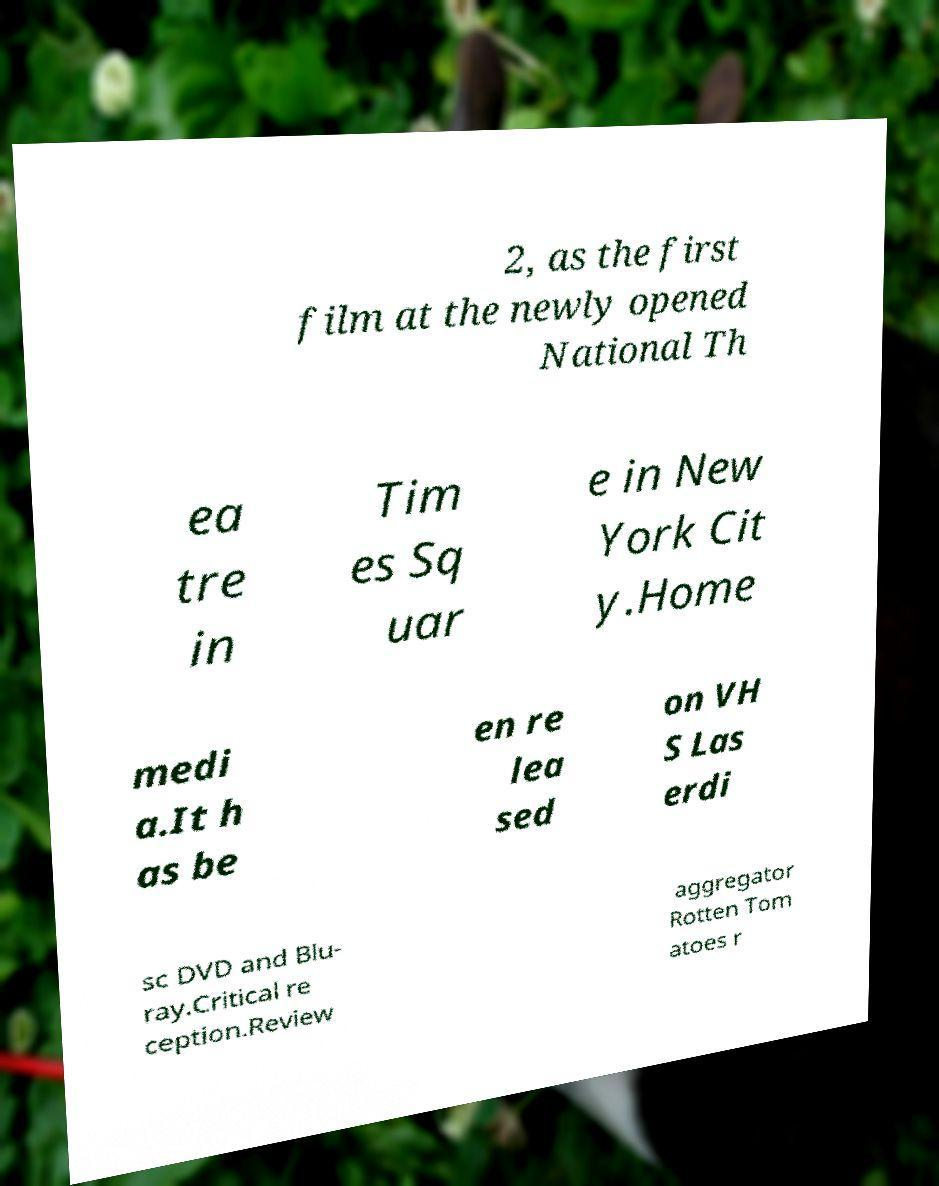Can you accurately transcribe the text from the provided image for me? 2, as the first film at the newly opened National Th ea tre in Tim es Sq uar e in New York Cit y.Home medi a.It h as be en re lea sed on VH S Las erdi sc DVD and Blu- ray.Critical re ception.Review aggregator Rotten Tom atoes r 